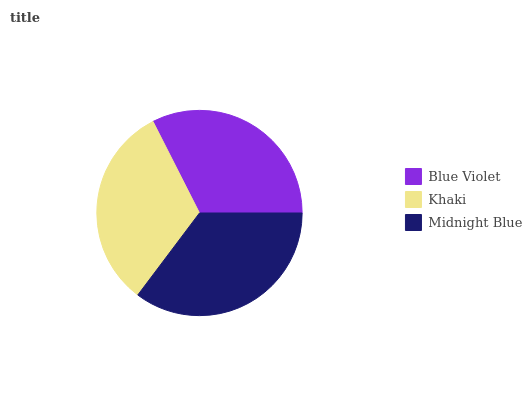Is Khaki the minimum?
Answer yes or no. Yes. Is Midnight Blue the maximum?
Answer yes or no. Yes. Is Midnight Blue the minimum?
Answer yes or no. No. Is Khaki the maximum?
Answer yes or no. No. Is Midnight Blue greater than Khaki?
Answer yes or no. Yes. Is Khaki less than Midnight Blue?
Answer yes or no. Yes. Is Khaki greater than Midnight Blue?
Answer yes or no. No. Is Midnight Blue less than Khaki?
Answer yes or no. No. Is Blue Violet the high median?
Answer yes or no. Yes. Is Blue Violet the low median?
Answer yes or no. Yes. Is Midnight Blue the high median?
Answer yes or no. No. Is Khaki the low median?
Answer yes or no. No. 